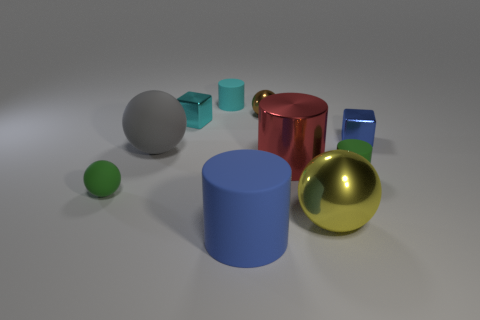Are there any blue cylinders that have the same size as the gray sphere? Yes, there is one blue cylinder in the image that appears to have a similar height to the gray sphere. The blue cylinder is positioned towards the left in the image, while the gray sphere is slightly to its right. 